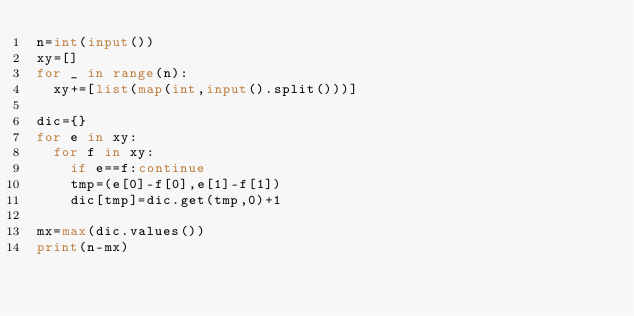<code> <loc_0><loc_0><loc_500><loc_500><_Python_>n=int(input())
xy=[]
for _ in range(n):
	xy+=[list(map(int,input().split()))]

dic={}
for e in xy:
	for f in xy:
		if e==f:continue
		tmp=(e[0]-f[0],e[1]-f[1])
		dic[tmp]=dic.get(tmp,0)+1

mx=max(dic.values())
print(n-mx)

</code> 